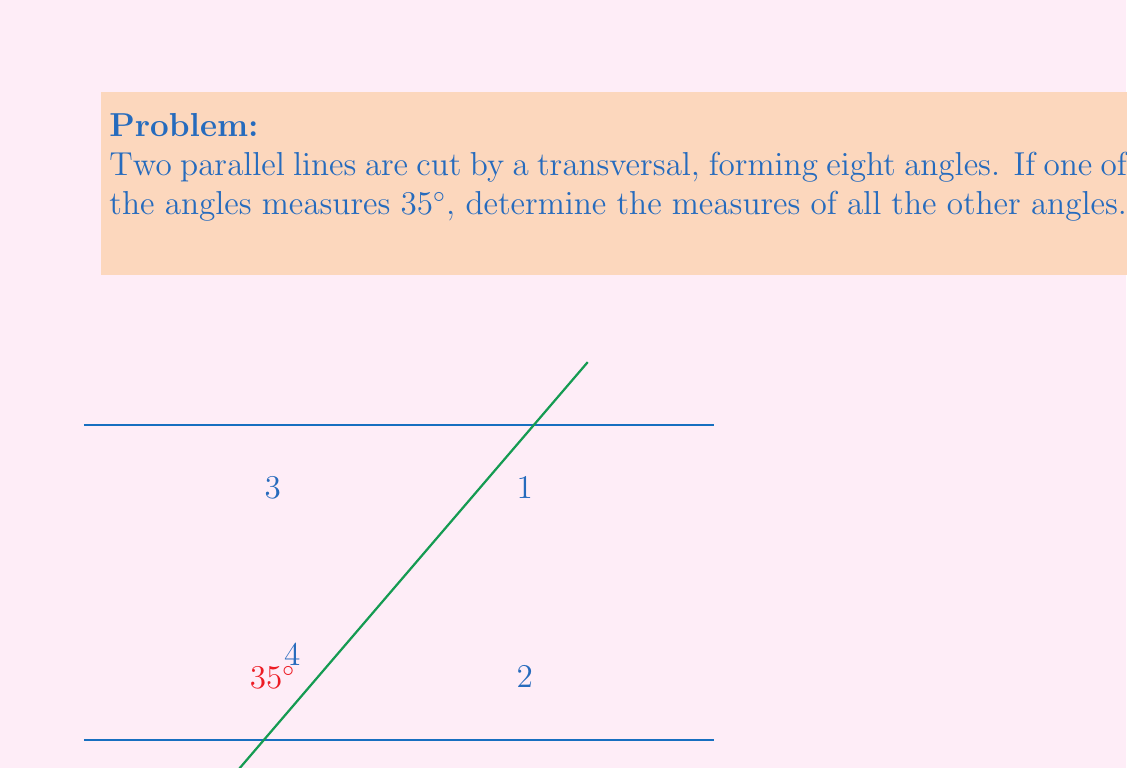Provide a solution to this math problem. Let's approach this step-by-step:

1) In the diagram, we have two parallel lines cut by a transversal, creating eight angles. One of these angles is given as $35°$.

2) Key concepts to remember:
   - Corresponding angles are congruent
   - Alternate interior angles are congruent
   - Alternate exterior angles are congruent
   - Consecutive interior angles are supplementary (sum to $180°$)

3) The $35°$ angle and angle 4 form a linear pair, so they are supplementary:
   $35° + x = 180°$
   $x = 180° - 35° = 145°$

4) Angle 4 is $145°$

5) Angle 3 is corresponding to the $35°$ angle, so it's also $35°$

6) Angle 1 is corresponding to angle 4, so it's also $145°$

7) Angle 2 and angle 1 form a linear pair, so:
   $145° + y = 180°$
   $y = 180° - 145° = 35°$

8) Angle 2 is $35°$

9) The remaining four angles on the other side of the transversal will follow the same pattern due to the properties of parallel lines cut by a transversal.

Therefore, the eight angles measure: $35°, 145°, 35°, 145°, 35°, 145°, 35°, 145°$.
Answer: $35°, 145°, 35°, 145°, 35°, 145°, 35°, 145°$ 